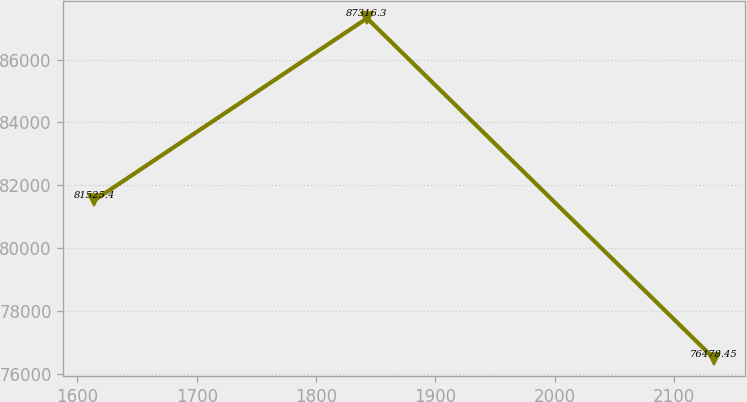Convert chart to OTSL. <chart><loc_0><loc_0><loc_500><loc_500><line_chart><ecel><fcel>Unnamed: 1<nl><fcel>1614.27<fcel>81525.4<nl><fcel>1842.8<fcel>87316.3<nl><fcel>2133.84<fcel>76478.4<nl></chart> 